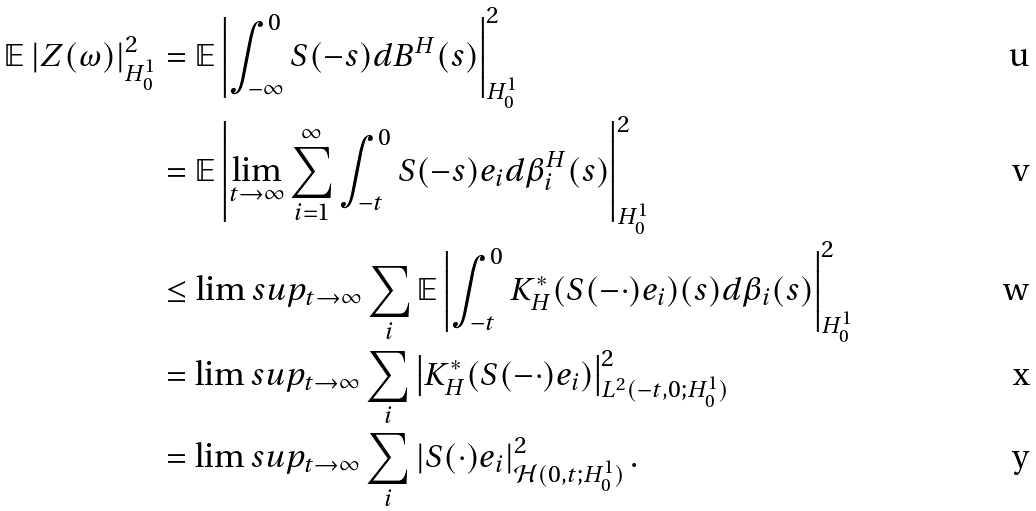<formula> <loc_0><loc_0><loc_500><loc_500>\mathbb { E } \left | Z ( \omega ) \right | _ { H _ { 0 } ^ { 1 } } ^ { 2 } & = \mathbb { E } \left | \int _ { - \infty } ^ { 0 } S ( - s ) d B ^ { H } ( s ) \right | _ { H _ { 0 } ^ { 1 } } ^ { 2 } \\ & = \mathbb { E } \left | \lim _ { t \rightarrow \infty } \sum _ { i = 1 } ^ { \infty } \int _ { - t } ^ { 0 } S ( - s ) e _ { i } d \beta _ { i } ^ { H } ( s ) \right | _ { H _ { 0 } ^ { 1 } } ^ { 2 } \\ & \leq \lim s u p _ { t \rightarrow \infty } \sum _ { i } \mathbb { E } \left | \int _ { - t } ^ { 0 } K _ { H } ^ { * } ( S ( - \cdot ) e _ { i } ) ( s ) d \beta _ { i } ( s ) \right | _ { H _ { 0 } ^ { 1 } } ^ { 2 } \\ & = \lim s u p _ { t \rightarrow \infty } \sum _ { i } \left | K _ { H } ^ { * } ( S ( - \cdot ) e _ { i } ) \right | _ { L ^ { 2 } ( - t , 0 ; H _ { 0 } ^ { 1 } ) } ^ { 2 } \\ & = \lim s u p _ { t \rightarrow \infty } \sum _ { i } \left | S ( \cdot ) e _ { i } \right | _ { \mathcal { H } ( 0 , t ; H _ { 0 } ^ { 1 } ) } ^ { 2 } .</formula> 